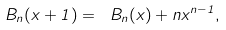Convert formula to latex. <formula><loc_0><loc_0><loc_500><loc_500>\ B _ { n } ( x + 1 ) = \ B _ { n } ( x ) + n x ^ { n - 1 } ,</formula> 